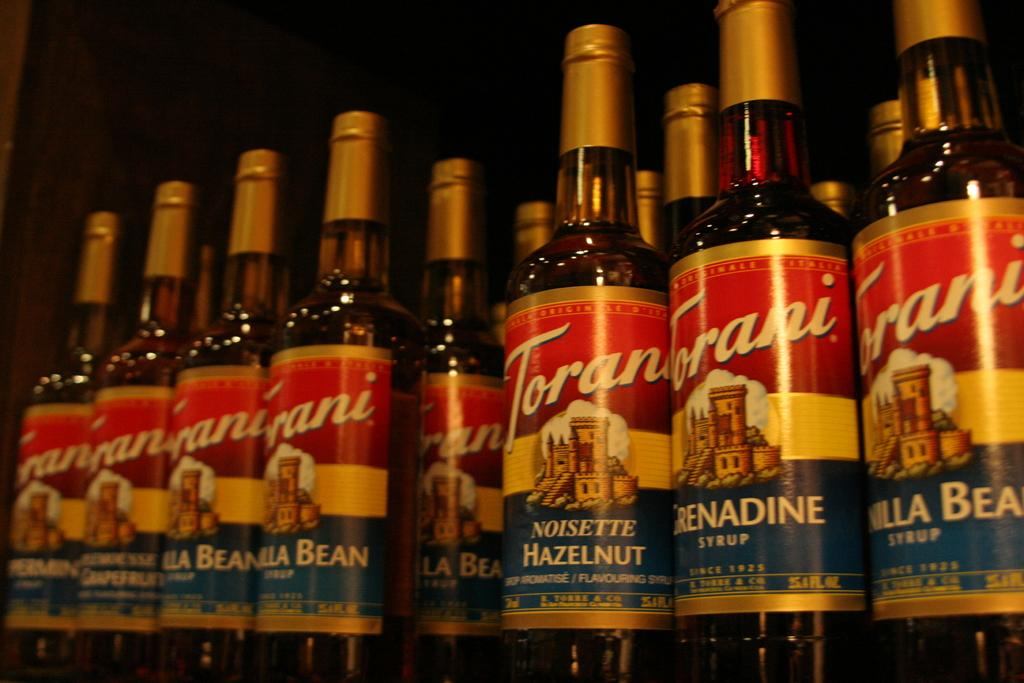<image>
Present a compact description of the photo's key features. Many different flavored bottles of Torani Syrup are lined up, including Hazelnut and Grenadine. 